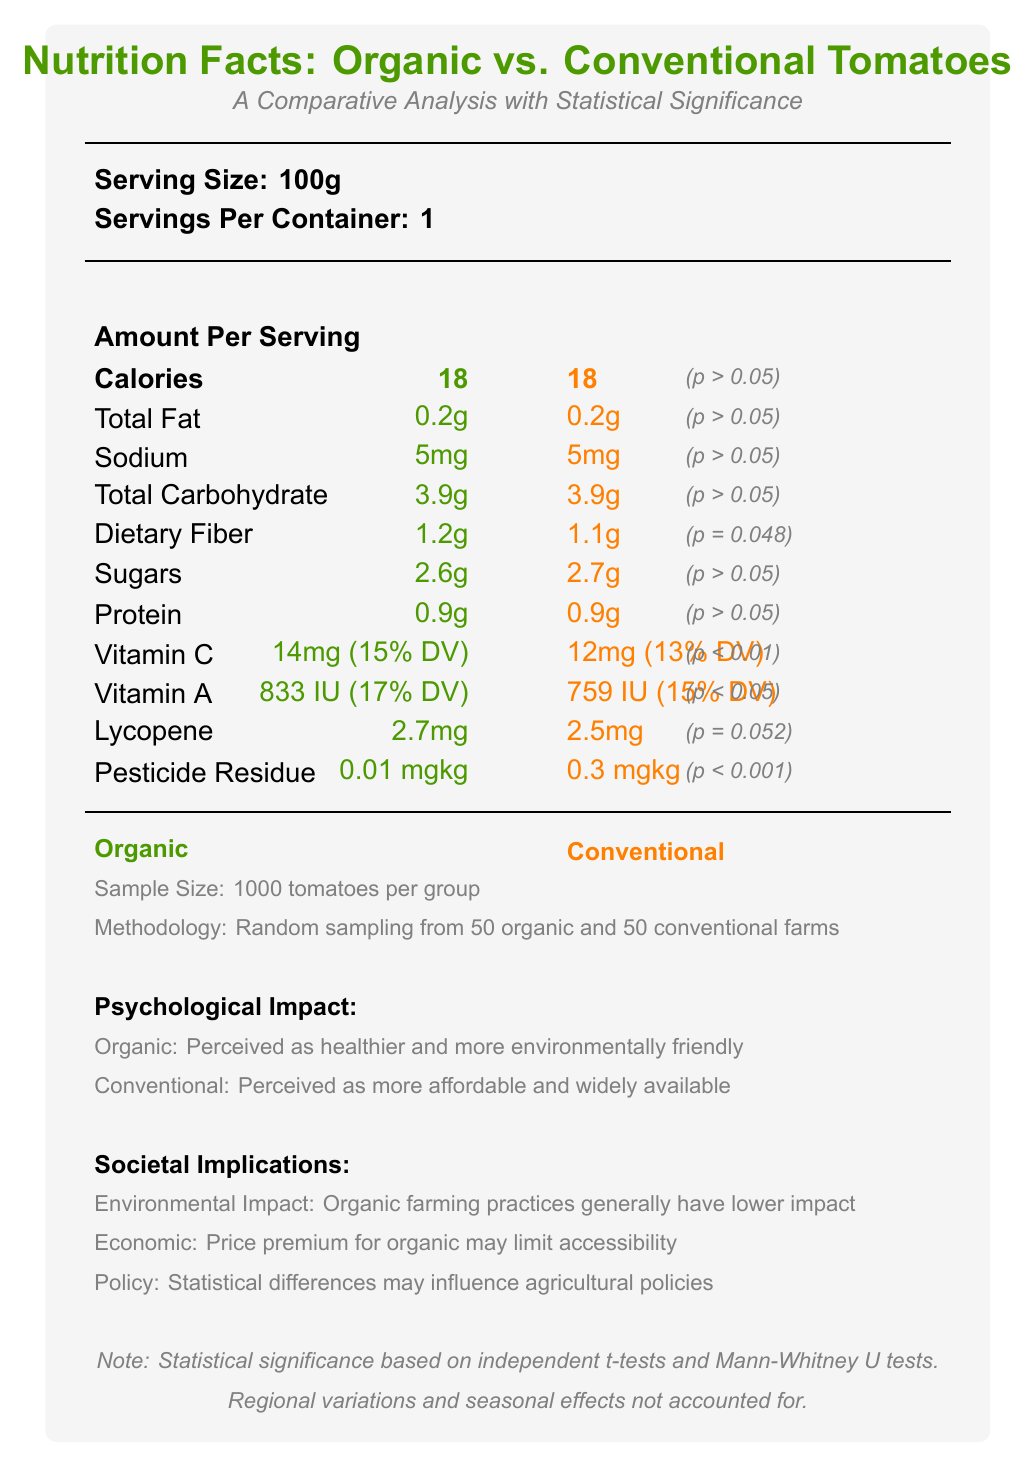what is the serving size for the tomatoes? The serving size for the tomatoes is explicitly stated as 100g in the document.
Answer: 100g How many servings are there per container? The document states there is 1 serving per container.
Answer: 1 What is the number of calories in 100g of both organic and conventional tomatoes? Both types of tomatoes have 18 calories according to the document.
Answer: 18 Is there a significant difference in the sodium content between organic and conventional tomatoes? The document indicates "No significant difference (p > 0.05)" in the sodium content between organic and conventional tomatoes.
Answer: No Which nutrient shows a marginally significant difference in its content between organic and conventional tomatoes? The document shows a marginally significant difference (p = 0.052) in lycopene.
Answer: Lycopene Is the difference in dietary fiber between organic and conventional tomatoes considered statistically significant? The document indicates a "Marginally significant difference (p = 0.048)" for dietary fiber.
Answer: Yes What is the pesticide residue level in conventional tomatoes? The document specifies that the pesticide residue level in conventional tomatoes is 0.3 mg/kg.
Answer: 0.3 mg/kg Which vitamin shows a more considerable significant difference in its content between organic and conventional tomatoes? 
A. Vitamin C 
B. Vitamin A 
C. Lycopene The document shows a significant difference in Vitamin C content (p < 0.01), whereas Vitamin A has a significant difference (p < 0.05), and Lycopene has a marginally significant difference (p = 0.052).
Answer: A. Vitamin C What percentage of the daily value (DV) for Vitamin C is provided by 100g of organic tomatoes? 
I. 13%
II. 14%
III. 15% 
IV. 17% The document states that organic tomatoes provide 15% of the daily value for Vitamin C.
Answer: III. 15% Are organic tomatoes perceived as more affordable compared to conventional tomatoes? According to the document, conventional tomatoes are perceived as more affordable.
Answer: No Summarize the main idea of the document. The document provides a detailed comparison of organic and conventional tomatoes with emphasis on nutritional content and statistical significance, along with insights on psychological perceptions and societal impacts.
Answer: The document serves as a comparative nutrition facts label for organic and conventional tomatoes, highlighting the differences in nutritional content, pesticide residue, and the associated psychological and societal implications. Statistically significant differences were found in dietary fiber, Vitamin C, Vitamin A, lycopene, and pesticide residue levels. The psychological impact and societal implications of consuming organic vs. conventional produce are also discussed. What statistical methods were used in the study? The document mentions that independent t-tests and Mann-Whitney U tests were used to determine statistical significance.
Answer: Independent t-tests and Mann-Whitney U tests What is the limitation of the study mentioned in the document? The document states that regional variations and seasonal effects were limitations in the study.
Answer: Regional variations and seasonal effects were not accounted for What is the price of the tomatoes? The document does not provide any information regarding the price of organic or conventional tomatoes.
Answer: Cannot be determined 